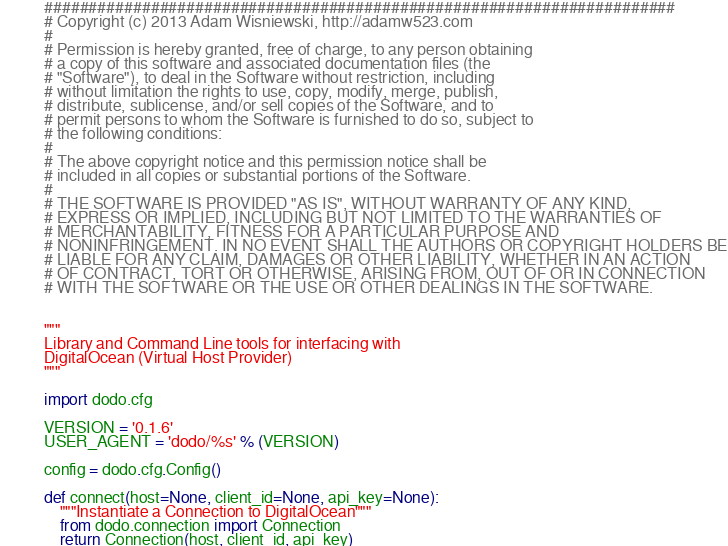Convert code to text. <code><loc_0><loc_0><loc_500><loc_500><_Python_>#######################################################################
# Copyright (c) 2013 Adam Wisniewski, http://adamw523.com
#
# Permission is hereby granted, free of charge, to any person obtaining
# a copy of this software and associated documentation files (the
# "Software"), to deal in the Software without restriction, including
# without limitation the rights to use, copy, modify, merge, publish,
# distribute, sublicense, and/or sell copies of the Software, and to
# permit persons to whom the Software is furnished to do so, subject to
# the following conditions:
#
# The above copyright notice and this permission notice shall be
# included in all copies or substantial portions of the Software.
#
# THE SOFTWARE IS PROVIDED "AS IS", WITHOUT WARRANTY OF ANY KIND,
# EXPRESS OR IMPLIED, INCLUDING BUT NOT LIMITED TO THE WARRANTIES OF
# MERCHANTABILITY, FITNESS FOR A PARTICULAR PURPOSE AND
# NONINFRINGEMENT. IN NO EVENT SHALL THE AUTHORS OR COPYRIGHT HOLDERS BE
# LIABLE FOR ANY CLAIM, DAMAGES OR OTHER LIABILITY, WHETHER IN AN ACTION
# OF CONTRACT, TORT OR OTHERWISE, ARISING FROM, OUT OF OR IN CONNECTION
# WITH THE SOFTWARE OR THE USE OR OTHER DEALINGS IN THE SOFTWARE.


"""
Library and Command Line tools for interfacing with
DigitalOcean (Virtual Host Provider)
"""

import dodo.cfg

VERSION = '0.1.6'
USER_AGENT = 'dodo/%s' % (VERSION)

config = dodo.cfg.Config()

def connect(host=None, client_id=None, api_key=None):
    """Instantiate a Connection to DigitalOcean"""
    from dodo.connection import Connection
    return Connection(host, client_id, api_key)

</code> 